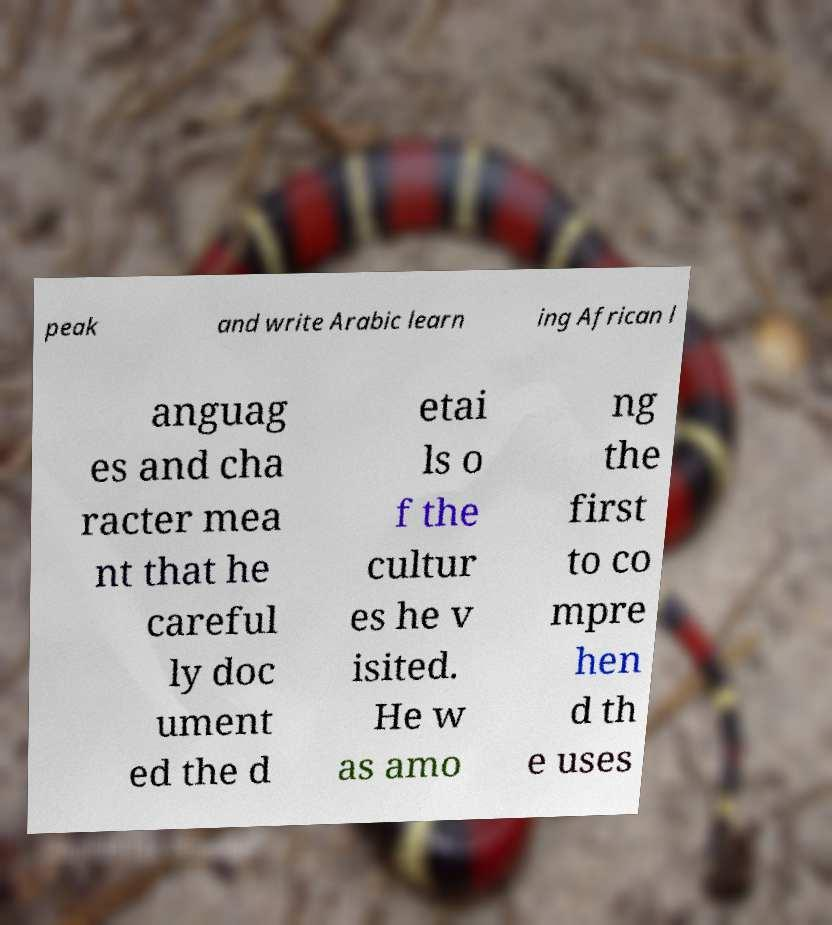Please identify and transcribe the text found in this image. peak and write Arabic learn ing African l anguag es and cha racter mea nt that he careful ly doc ument ed the d etai ls o f the cultur es he v isited. He w as amo ng the first to co mpre hen d th e uses 